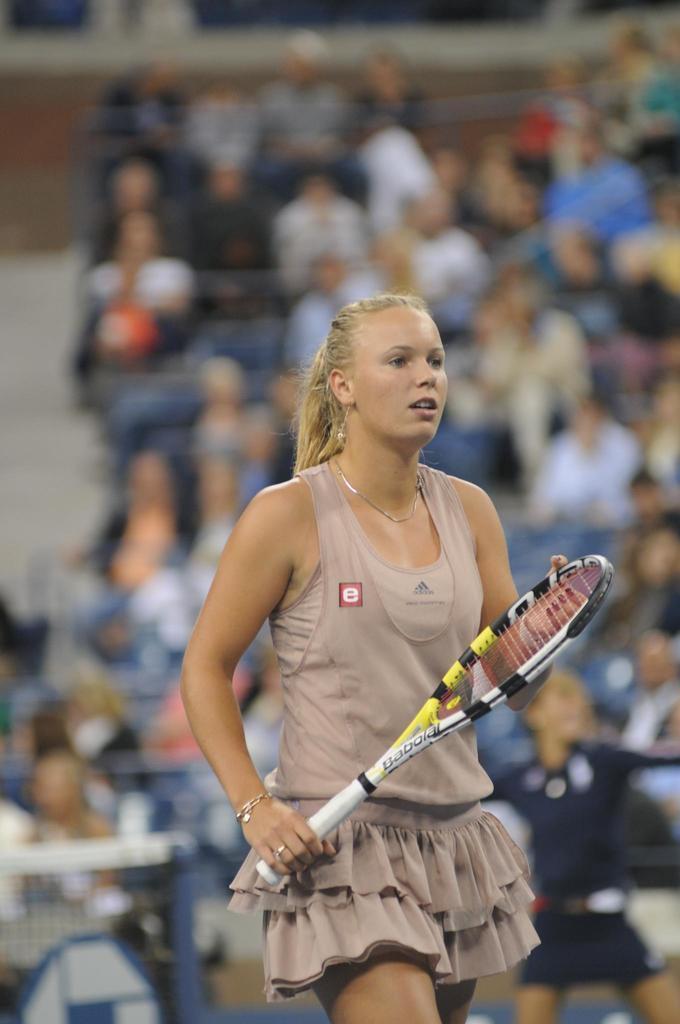Please provide a concise description of this image. This picture is taken in a stadium, In the middle there is a woman she is standing and holding a bat which is in white color, In the background there are some people sitting on the chairs. 